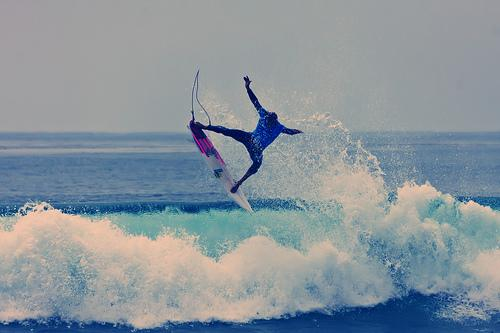Identify the sentiment of the image based on the visual elements. The sentiment of the image is adventurous and thrilling, as the surfer is catching air in the midst of a large wave. What can you tell me about the color palette used in this image? The image mainly consists of colors such as blue from the ocean and sky, grey from the sky, white from the splash of water and surfboard, and pink from the surfboard designs. What gear or equipment can be seen on the surfer? The surfer is wearing a blue and black wetsuit, possibly a blue rash guard, and has a strap on his ankle tethered to the surfboard. What can be inferred about the surfer's skill and experience? The surfer appears experienced and skilled, as he is catching air, maintaining balance, and navigating a large wave. Estimate how many different visible objects can be found in the image. At least 15 distinct objects can be identified in the image. What objects can you identify in this image? A wave, ocean waters, surfboard, surfer, wetsuit, splash of water, flat and elevated areas of water, strap on ankle, designs on the board, and grey sky. Mention an action the surfer is performing and the state of the wave. The surfer is jumping off the top of the wave, and the wave is breaking in the ocean. Describe the appearance of the surfboard in this image. The surfboard is white with pink designs, neon pink elements, and blue and pink images. It has a piece at the end and a chord connected to its base. Analyze the quality of the image considering sharpness and details. The image appears to be high quality with sharp details, as many specific elements like the surfer's head and strap on the ankle are visible. Propose a possible goal or challenge for the surfer in the image. The surfer might be aiming to catch air, ride the large wave successfully, and maintain balance throughout the surfing experience. 